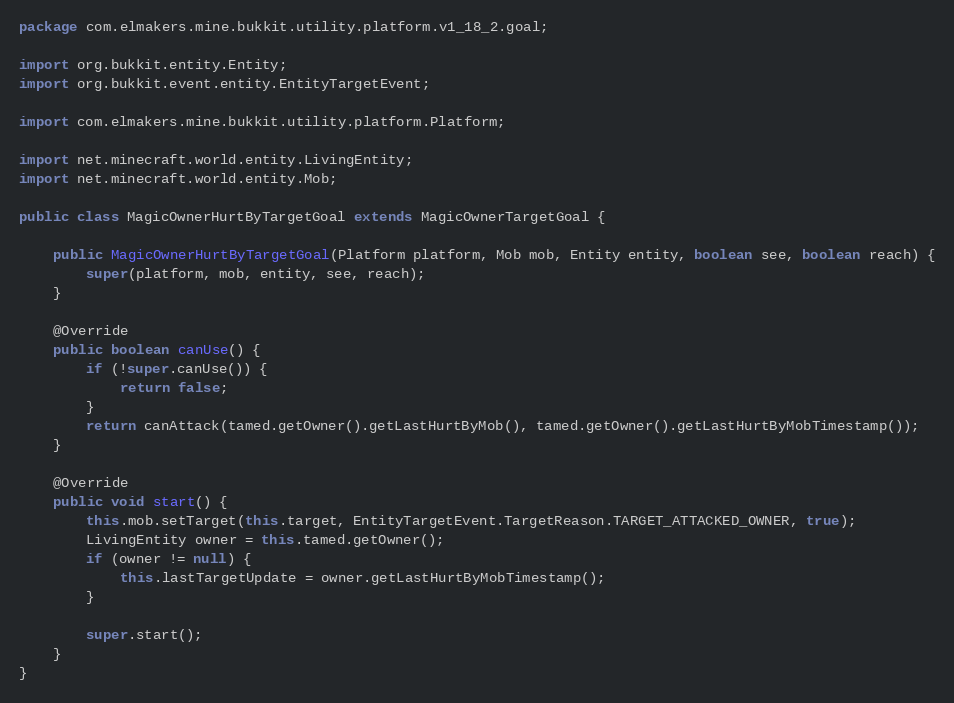<code> <loc_0><loc_0><loc_500><loc_500><_Java_>package com.elmakers.mine.bukkit.utility.platform.v1_18_2.goal;

import org.bukkit.entity.Entity;
import org.bukkit.event.entity.EntityTargetEvent;

import com.elmakers.mine.bukkit.utility.platform.Platform;

import net.minecraft.world.entity.LivingEntity;
import net.minecraft.world.entity.Mob;

public class MagicOwnerHurtByTargetGoal extends MagicOwnerTargetGoal {

    public MagicOwnerHurtByTargetGoal(Platform platform, Mob mob, Entity entity, boolean see, boolean reach) {
        super(platform, mob, entity, see, reach);
    }

    @Override
    public boolean canUse() {
        if (!super.canUse()) {
            return false;
        }
        return canAttack(tamed.getOwner().getLastHurtByMob(), tamed.getOwner().getLastHurtByMobTimestamp());
    }

    @Override
    public void start() {
        this.mob.setTarget(this.target, EntityTargetEvent.TargetReason.TARGET_ATTACKED_OWNER, true);
        LivingEntity owner = this.tamed.getOwner();
        if (owner != null) {
            this.lastTargetUpdate = owner.getLastHurtByMobTimestamp();
        }

        super.start();
    }
}
</code> 